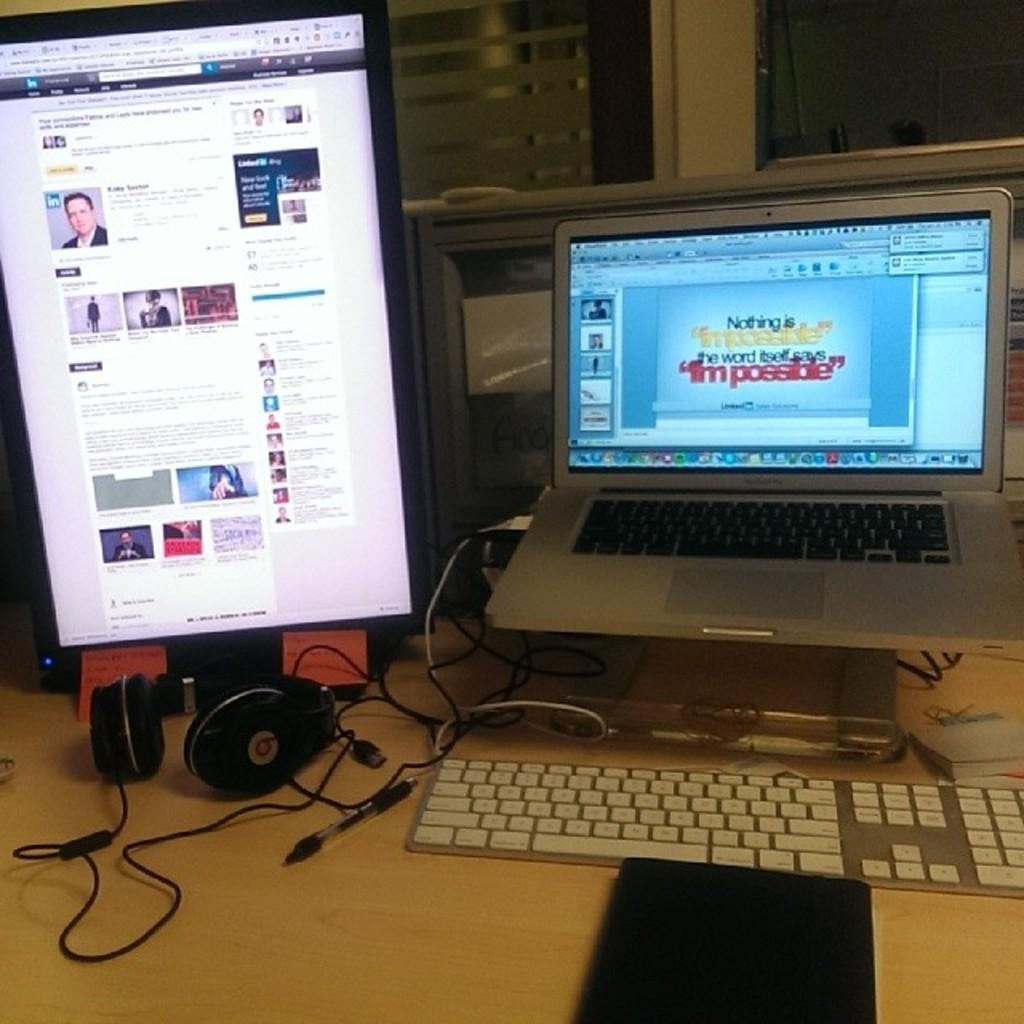<image>
Give a short and clear explanation of the subsequent image. A webscreen opened on a laptop with the word impossible on it twice. 